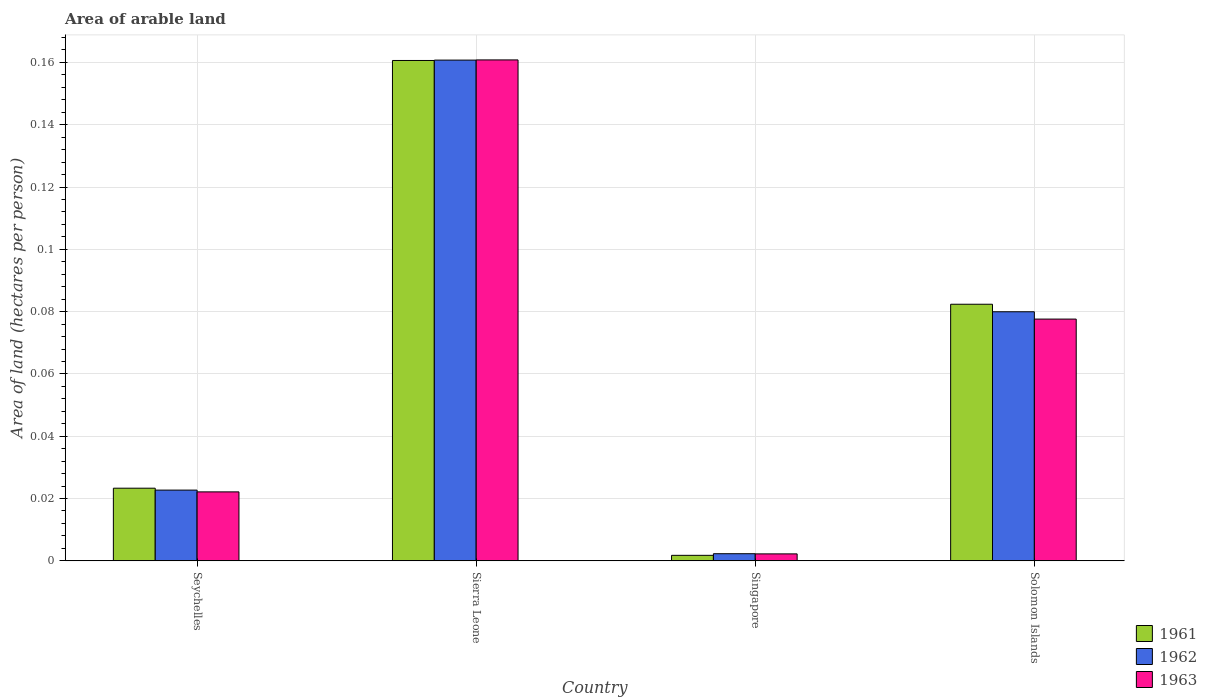How many different coloured bars are there?
Offer a terse response. 3. Are the number of bars on each tick of the X-axis equal?
Keep it short and to the point. Yes. How many bars are there on the 1st tick from the left?
Make the answer very short. 3. How many bars are there on the 4th tick from the right?
Provide a short and direct response. 3. What is the label of the 4th group of bars from the left?
Make the answer very short. Solomon Islands. In how many cases, is the number of bars for a given country not equal to the number of legend labels?
Your answer should be compact. 0. What is the total arable land in 1961 in Seychelles?
Provide a short and direct response. 0.02. Across all countries, what is the maximum total arable land in 1963?
Your answer should be very brief. 0.16. Across all countries, what is the minimum total arable land in 1961?
Ensure brevity in your answer.  0. In which country was the total arable land in 1962 maximum?
Your answer should be compact. Sierra Leone. In which country was the total arable land in 1963 minimum?
Your answer should be very brief. Singapore. What is the total total arable land in 1961 in the graph?
Your answer should be compact. 0.27. What is the difference between the total arable land in 1962 in Seychelles and that in Solomon Islands?
Provide a short and direct response. -0.06. What is the difference between the total arable land in 1962 in Seychelles and the total arable land in 1961 in Sierra Leone?
Ensure brevity in your answer.  -0.14. What is the average total arable land in 1961 per country?
Your answer should be compact. 0.07. What is the difference between the total arable land of/in 1963 and total arable land of/in 1961 in Solomon Islands?
Provide a short and direct response. -0. In how many countries, is the total arable land in 1963 greater than 0.112 hectares per person?
Provide a succinct answer. 1. What is the ratio of the total arable land in 1963 in Sierra Leone to that in Singapore?
Provide a short and direct response. 72.16. Is the total arable land in 1963 in Seychelles less than that in Sierra Leone?
Provide a short and direct response. Yes. What is the difference between the highest and the second highest total arable land in 1961?
Offer a very short reply. 0.14. What is the difference between the highest and the lowest total arable land in 1963?
Make the answer very short. 0.16. Is the sum of the total arable land in 1961 in Seychelles and Solomon Islands greater than the maximum total arable land in 1962 across all countries?
Keep it short and to the point. No. What does the 2nd bar from the right in Solomon Islands represents?
Provide a succinct answer. 1962. Are all the bars in the graph horizontal?
Provide a succinct answer. No. Where does the legend appear in the graph?
Give a very brief answer. Bottom right. How many legend labels are there?
Your response must be concise. 3. How are the legend labels stacked?
Provide a succinct answer. Vertical. What is the title of the graph?
Provide a succinct answer. Area of arable land. Does "1991" appear as one of the legend labels in the graph?
Make the answer very short. No. What is the label or title of the X-axis?
Provide a short and direct response. Country. What is the label or title of the Y-axis?
Offer a terse response. Area of land (hectares per person). What is the Area of land (hectares per person) in 1961 in Seychelles?
Ensure brevity in your answer.  0.02. What is the Area of land (hectares per person) of 1962 in Seychelles?
Your answer should be very brief. 0.02. What is the Area of land (hectares per person) in 1963 in Seychelles?
Your answer should be very brief. 0.02. What is the Area of land (hectares per person) of 1961 in Sierra Leone?
Provide a short and direct response. 0.16. What is the Area of land (hectares per person) of 1962 in Sierra Leone?
Your answer should be compact. 0.16. What is the Area of land (hectares per person) of 1963 in Sierra Leone?
Your response must be concise. 0.16. What is the Area of land (hectares per person) in 1961 in Singapore?
Keep it short and to the point. 0. What is the Area of land (hectares per person) in 1962 in Singapore?
Ensure brevity in your answer.  0. What is the Area of land (hectares per person) in 1963 in Singapore?
Ensure brevity in your answer.  0. What is the Area of land (hectares per person) in 1961 in Solomon Islands?
Offer a very short reply. 0.08. What is the Area of land (hectares per person) of 1962 in Solomon Islands?
Keep it short and to the point. 0.08. What is the Area of land (hectares per person) in 1963 in Solomon Islands?
Provide a succinct answer. 0.08. Across all countries, what is the maximum Area of land (hectares per person) in 1961?
Your answer should be very brief. 0.16. Across all countries, what is the maximum Area of land (hectares per person) of 1962?
Your response must be concise. 0.16. Across all countries, what is the maximum Area of land (hectares per person) of 1963?
Provide a short and direct response. 0.16. Across all countries, what is the minimum Area of land (hectares per person) of 1961?
Make the answer very short. 0. Across all countries, what is the minimum Area of land (hectares per person) of 1962?
Ensure brevity in your answer.  0. Across all countries, what is the minimum Area of land (hectares per person) in 1963?
Make the answer very short. 0. What is the total Area of land (hectares per person) of 1961 in the graph?
Your answer should be compact. 0.27. What is the total Area of land (hectares per person) in 1962 in the graph?
Ensure brevity in your answer.  0.27. What is the total Area of land (hectares per person) of 1963 in the graph?
Your answer should be compact. 0.26. What is the difference between the Area of land (hectares per person) of 1961 in Seychelles and that in Sierra Leone?
Offer a terse response. -0.14. What is the difference between the Area of land (hectares per person) of 1962 in Seychelles and that in Sierra Leone?
Offer a terse response. -0.14. What is the difference between the Area of land (hectares per person) of 1963 in Seychelles and that in Sierra Leone?
Your answer should be compact. -0.14. What is the difference between the Area of land (hectares per person) in 1961 in Seychelles and that in Singapore?
Provide a short and direct response. 0.02. What is the difference between the Area of land (hectares per person) in 1962 in Seychelles and that in Singapore?
Offer a terse response. 0.02. What is the difference between the Area of land (hectares per person) in 1963 in Seychelles and that in Singapore?
Make the answer very short. 0.02. What is the difference between the Area of land (hectares per person) of 1961 in Seychelles and that in Solomon Islands?
Make the answer very short. -0.06. What is the difference between the Area of land (hectares per person) in 1962 in Seychelles and that in Solomon Islands?
Your answer should be compact. -0.06. What is the difference between the Area of land (hectares per person) of 1963 in Seychelles and that in Solomon Islands?
Make the answer very short. -0.06. What is the difference between the Area of land (hectares per person) of 1961 in Sierra Leone and that in Singapore?
Your response must be concise. 0.16. What is the difference between the Area of land (hectares per person) of 1962 in Sierra Leone and that in Singapore?
Provide a succinct answer. 0.16. What is the difference between the Area of land (hectares per person) of 1963 in Sierra Leone and that in Singapore?
Ensure brevity in your answer.  0.16. What is the difference between the Area of land (hectares per person) in 1961 in Sierra Leone and that in Solomon Islands?
Provide a succinct answer. 0.08. What is the difference between the Area of land (hectares per person) in 1962 in Sierra Leone and that in Solomon Islands?
Give a very brief answer. 0.08. What is the difference between the Area of land (hectares per person) of 1963 in Sierra Leone and that in Solomon Islands?
Offer a very short reply. 0.08. What is the difference between the Area of land (hectares per person) in 1961 in Singapore and that in Solomon Islands?
Your answer should be very brief. -0.08. What is the difference between the Area of land (hectares per person) in 1962 in Singapore and that in Solomon Islands?
Keep it short and to the point. -0.08. What is the difference between the Area of land (hectares per person) of 1963 in Singapore and that in Solomon Islands?
Provide a short and direct response. -0.08. What is the difference between the Area of land (hectares per person) of 1961 in Seychelles and the Area of land (hectares per person) of 1962 in Sierra Leone?
Offer a terse response. -0.14. What is the difference between the Area of land (hectares per person) of 1961 in Seychelles and the Area of land (hectares per person) of 1963 in Sierra Leone?
Offer a terse response. -0.14. What is the difference between the Area of land (hectares per person) of 1962 in Seychelles and the Area of land (hectares per person) of 1963 in Sierra Leone?
Give a very brief answer. -0.14. What is the difference between the Area of land (hectares per person) of 1961 in Seychelles and the Area of land (hectares per person) of 1962 in Singapore?
Offer a terse response. 0.02. What is the difference between the Area of land (hectares per person) of 1961 in Seychelles and the Area of land (hectares per person) of 1963 in Singapore?
Your answer should be compact. 0.02. What is the difference between the Area of land (hectares per person) of 1962 in Seychelles and the Area of land (hectares per person) of 1963 in Singapore?
Ensure brevity in your answer.  0.02. What is the difference between the Area of land (hectares per person) of 1961 in Seychelles and the Area of land (hectares per person) of 1962 in Solomon Islands?
Offer a terse response. -0.06. What is the difference between the Area of land (hectares per person) of 1961 in Seychelles and the Area of land (hectares per person) of 1963 in Solomon Islands?
Offer a very short reply. -0.05. What is the difference between the Area of land (hectares per person) in 1962 in Seychelles and the Area of land (hectares per person) in 1963 in Solomon Islands?
Offer a very short reply. -0.05. What is the difference between the Area of land (hectares per person) of 1961 in Sierra Leone and the Area of land (hectares per person) of 1962 in Singapore?
Offer a very short reply. 0.16. What is the difference between the Area of land (hectares per person) in 1961 in Sierra Leone and the Area of land (hectares per person) in 1963 in Singapore?
Give a very brief answer. 0.16. What is the difference between the Area of land (hectares per person) in 1962 in Sierra Leone and the Area of land (hectares per person) in 1963 in Singapore?
Provide a succinct answer. 0.16. What is the difference between the Area of land (hectares per person) of 1961 in Sierra Leone and the Area of land (hectares per person) of 1962 in Solomon Islands?
Make the answer very short. 0.08. What is the difference between the Area of land (hectares per person) in 1961 in Sierra Leone and the Area of land (hectares per person) in 1963 in Solomon Islands?
Give a very brief answer. 0.08. What is the difference between the Area of land (hectares per person) in 1962 in Sierra Leone and the Area of land (hectares per person) in 1963 in Solomon Islands?
Your response must be concise. 0.08. What is the difference between the Area of land (hectares per person) of 1961 in Singapore and the Area of land (hectares per person) of 1962 in Solomon Islands?
Your response must be concise. -0.08. What is the difference between the Area of land (hectares per person) of 1961 in Singapore and the Area of land (hectares per person) of 1963 in Solomon Islands?
Make the answer very short. -0.08. What is the difference between the Area of land (hectares per person) of 1962 in Singapore and the Area of land (hectares per person) of 1963 in Solomon Islands?
Make the answer very short. -0.08. What is the average Area of land (hectares per person) of 1961 per country?
Your answer should be compact. 0.07. What is the average Area of land (hectares per person) in 1962 per country?
Offer a very short reply. 0.07. What is the average Area of land (hectares per person) in 1963 per country?
Offer a very short reply. 0.07. What is the difference between the Area of land (hectares per person) in 1961 and Area of land (hectares per person) in 1962 in Seychelles?
Keep it short and to the point. 0. What is the difference between the Area of land (hectares per person) of 1961 and Area of land (hectares per person) of 1963 in Seychelles?
Provide a short and direct response. 0. What is the difference between the Area of land (hectares per person) in 1962 and Area of land (hectares per person) in 1963 in Seychelles?
Ensure brevity in your answer.  0. What is the difference between the Area of land (hectares per person) in 1961 and Area of land (hectares per person) in 1962 in Sierra Leone?
Offer a very short reply. -0. What is the difference between the Area of land (hectares per person) in 1961 and Area of land (hectares per person) in 1963 in Sierra Leone?
Your response must be concise. -0. What is the difference between the Area of land (hectares per person) in 1962 and Area of land (hectares per person) in 1963 in Sierra Leone?
Offer a very short reply. -0. What is the difference between the Area of land (hectares per person) of 1961 and Area of land (hectares per person) of 1962 in Singapore?
Your answer should be compact. -0. What is the difference between the Area of land (hectares per person) in 1961 and Area of land (hectares per person) in 1963 in Singapore?
Provide a succinct answer. -0. What is the difference between the Area of land (hectares per person) in 1961 and Area of land (hectares per person) in 1962 in Solomon Islands?
Your answer should be very brief. 0. What is the difference between the Area of land (hectares per person) of 1961 and Area of land (hectares per person) of 1963 in Solomon Islands?
Your answer should be compact. 0. What is the difference between the Area of land (hectares per person) in 1962 and Area of land (hectares per person) in 1963 in Solomon Islands?
Your answer should be compact. 0. What is the ratio of the Area of land (hectares per person) of 1961 in Seychelles to that in Sierra Leone?
Your response must be concise. 0.15. What is the ratio of the Area of land (hectares per person) in 1962 in Seychelles to that in Sierra Leone?
Offer a very short reply. 0.14. What is the ratio of the Area of land (hectares per person) in 1963 in Seychelles to that in Sierra Leone?
Provide a succinct answer. 0.14. What is the ratio of the Area of land (hectares per person) of 1961 in Seychelles to that in Singapore?
Make the answer very short. 13.23. What is the ratio of the Area of land (hectares per person) in 1962 in Seychelles to that in Singapore?
Provide a short and direct response. 9.93. What is the ratio of the Area of land (hectares per person) in 1963 in Seychelles to that in Singapore?
Your answer should be compact. 9.93. What is the ratio of the Area of land (hectares per person) in 1961 in Seychelles to that in Solomon Islands?
Your response must be concise. 0.28. What is the ratio of the Area of land (hectares per person) in 1962 in Seychelles to that in Solomon Islands?
Your response must be concise. 0.28. What is the ratio of the Area of land (hectares per person) in 1963 in Seychelles to that in Solomon Islands?
Ensure brevity in your answer.  0.29. What is the ratio of the Area of land (hectares per person) in 1961 in Sierra Leone to that in Singapore?
Make the answer very short. 91.15. What is the ratio of the Area of land (hectares per person) in 1962 in Sierra Leone to that in Singapore?
Give a very brief answer. 70.33. What is the ratio of the Area of land (hectares per person) in 1963 in Sierra Leone to that in Singapore?
Provide a short and direct response. 72.16. What is the ratio of the Area of land (hectares per person) of 1961 in Sierra Leone to that in Solomon Islands?
Give a very brief answer. 1.95. What is the ratio of the Area of land (hectares per person) in 1962 in Sierra Leone to that in Solomon Islands?
Your answer should be compact. 2.01. What is the ratio of the Area of land (hectares per person) in 1963 in Sierra Leone to that in Solomon Islands?
Make the answer very short. 2.07. What is the ratio of the Area of land (hectares per person) in 1961 in Singapore to that in Solomon Islands?
Ensure brevity in your answer.  0.02. What is the ratio of the Area of land (hectares per person) in 1962 in Singapore to that in Solomon Islands?
Provide a succinct answer. 0.03. What is the ratio of the Area of land (hectares per person) in 1963 in Singapore to that in Solomon Islands?
Your answer should be very brief. 0.03. What is the difference between the highest and the second highest Area of land (hectares per person) of 1961?
Your answer should be compact. 0.08. What is the difference between the highest and the second highest Area of land (hectares per person) in 1962?
Give a very brief answer. 0.08. What is the difference between the highest and the second highest Area of land (hectares per person) of 1963?
Your answer should be very brief. 0.08. What is the difference between the highest and the lowest Area of land (hectares per person) of 1961?
Keep it short and to the point. 0.16. What is the difference between the highest and the lowest Area of land (hectares per person) in 1962?
Your answer should be very brief. 0.16. What is the difference between the highest and the lowest Area of land (hectares per person) of 1963?
Offer a terse response. 0.16. 